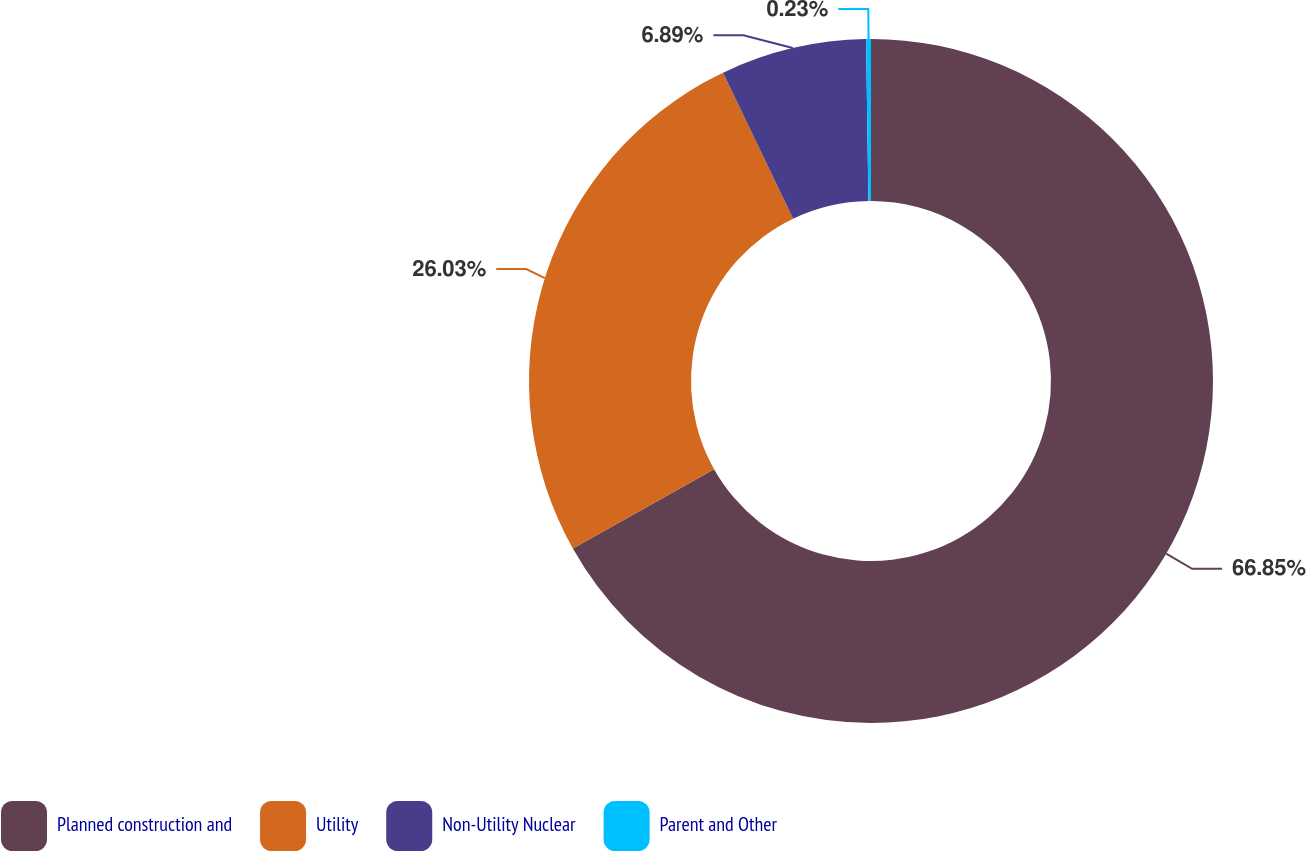Convert chart. <chart><loc_0><loc_0><loc_500><loc_500><pie_chart><fcel>Planned construction and<fcel>Utility<fcel>Non-Utility Nuclear<fcel>Parent and Other<nl><fcel>66.85%<fcel>26.03%<fcel>6.89%<fcel>0.23%<nl></chart> 